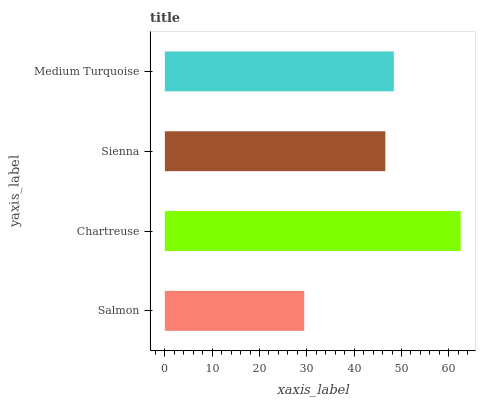Is Salmon the minimum?
Answer yes or no. Yes. Is Chartreuse the maximum?
Answer yes or no. Yes. Is Sienna the minimum?
Answer yes or no. No. Is Sienna the maximum?
Answer yes or no. No. Is Chartreuse greater than Sienna?
Answer yes or no. Yes. Is Sienna less than Chartreuse?
Answer yes or no. Yes. Is Sienna greater than Chartreuse?
Answer yes or no. No. Is Chartreuse less than Sienna?
Answer yes or no. No. Is Medium Turquoise the high median?
Answer yes or no. Yes. Is Sienna the low median?
Answer yes or no. Yes. Is Chartreuse the high median?
Answer yes or no. No. Is Chartreuse the low median?
Answer yes or no. No. 